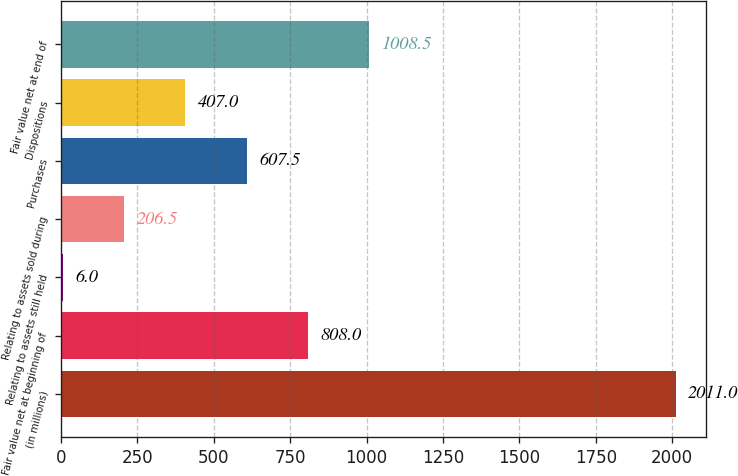Convert chart. <chart><loc_0><loc_0><loc_500><loc_500><bar_chart><fcel>(in millions)<fcel>Fair value net at beginning of<fcel>Relating to assets still held<fcel>Relating to assets sold during<fcel>Purchases<fcel>Dispositions<fcel>Fair value net at end of<nl><fcel>2011<fcel>808<fcel>6<fcel>206.5<fcel>607.5<fcel>407<fcel>1008.5<nl></chart> 